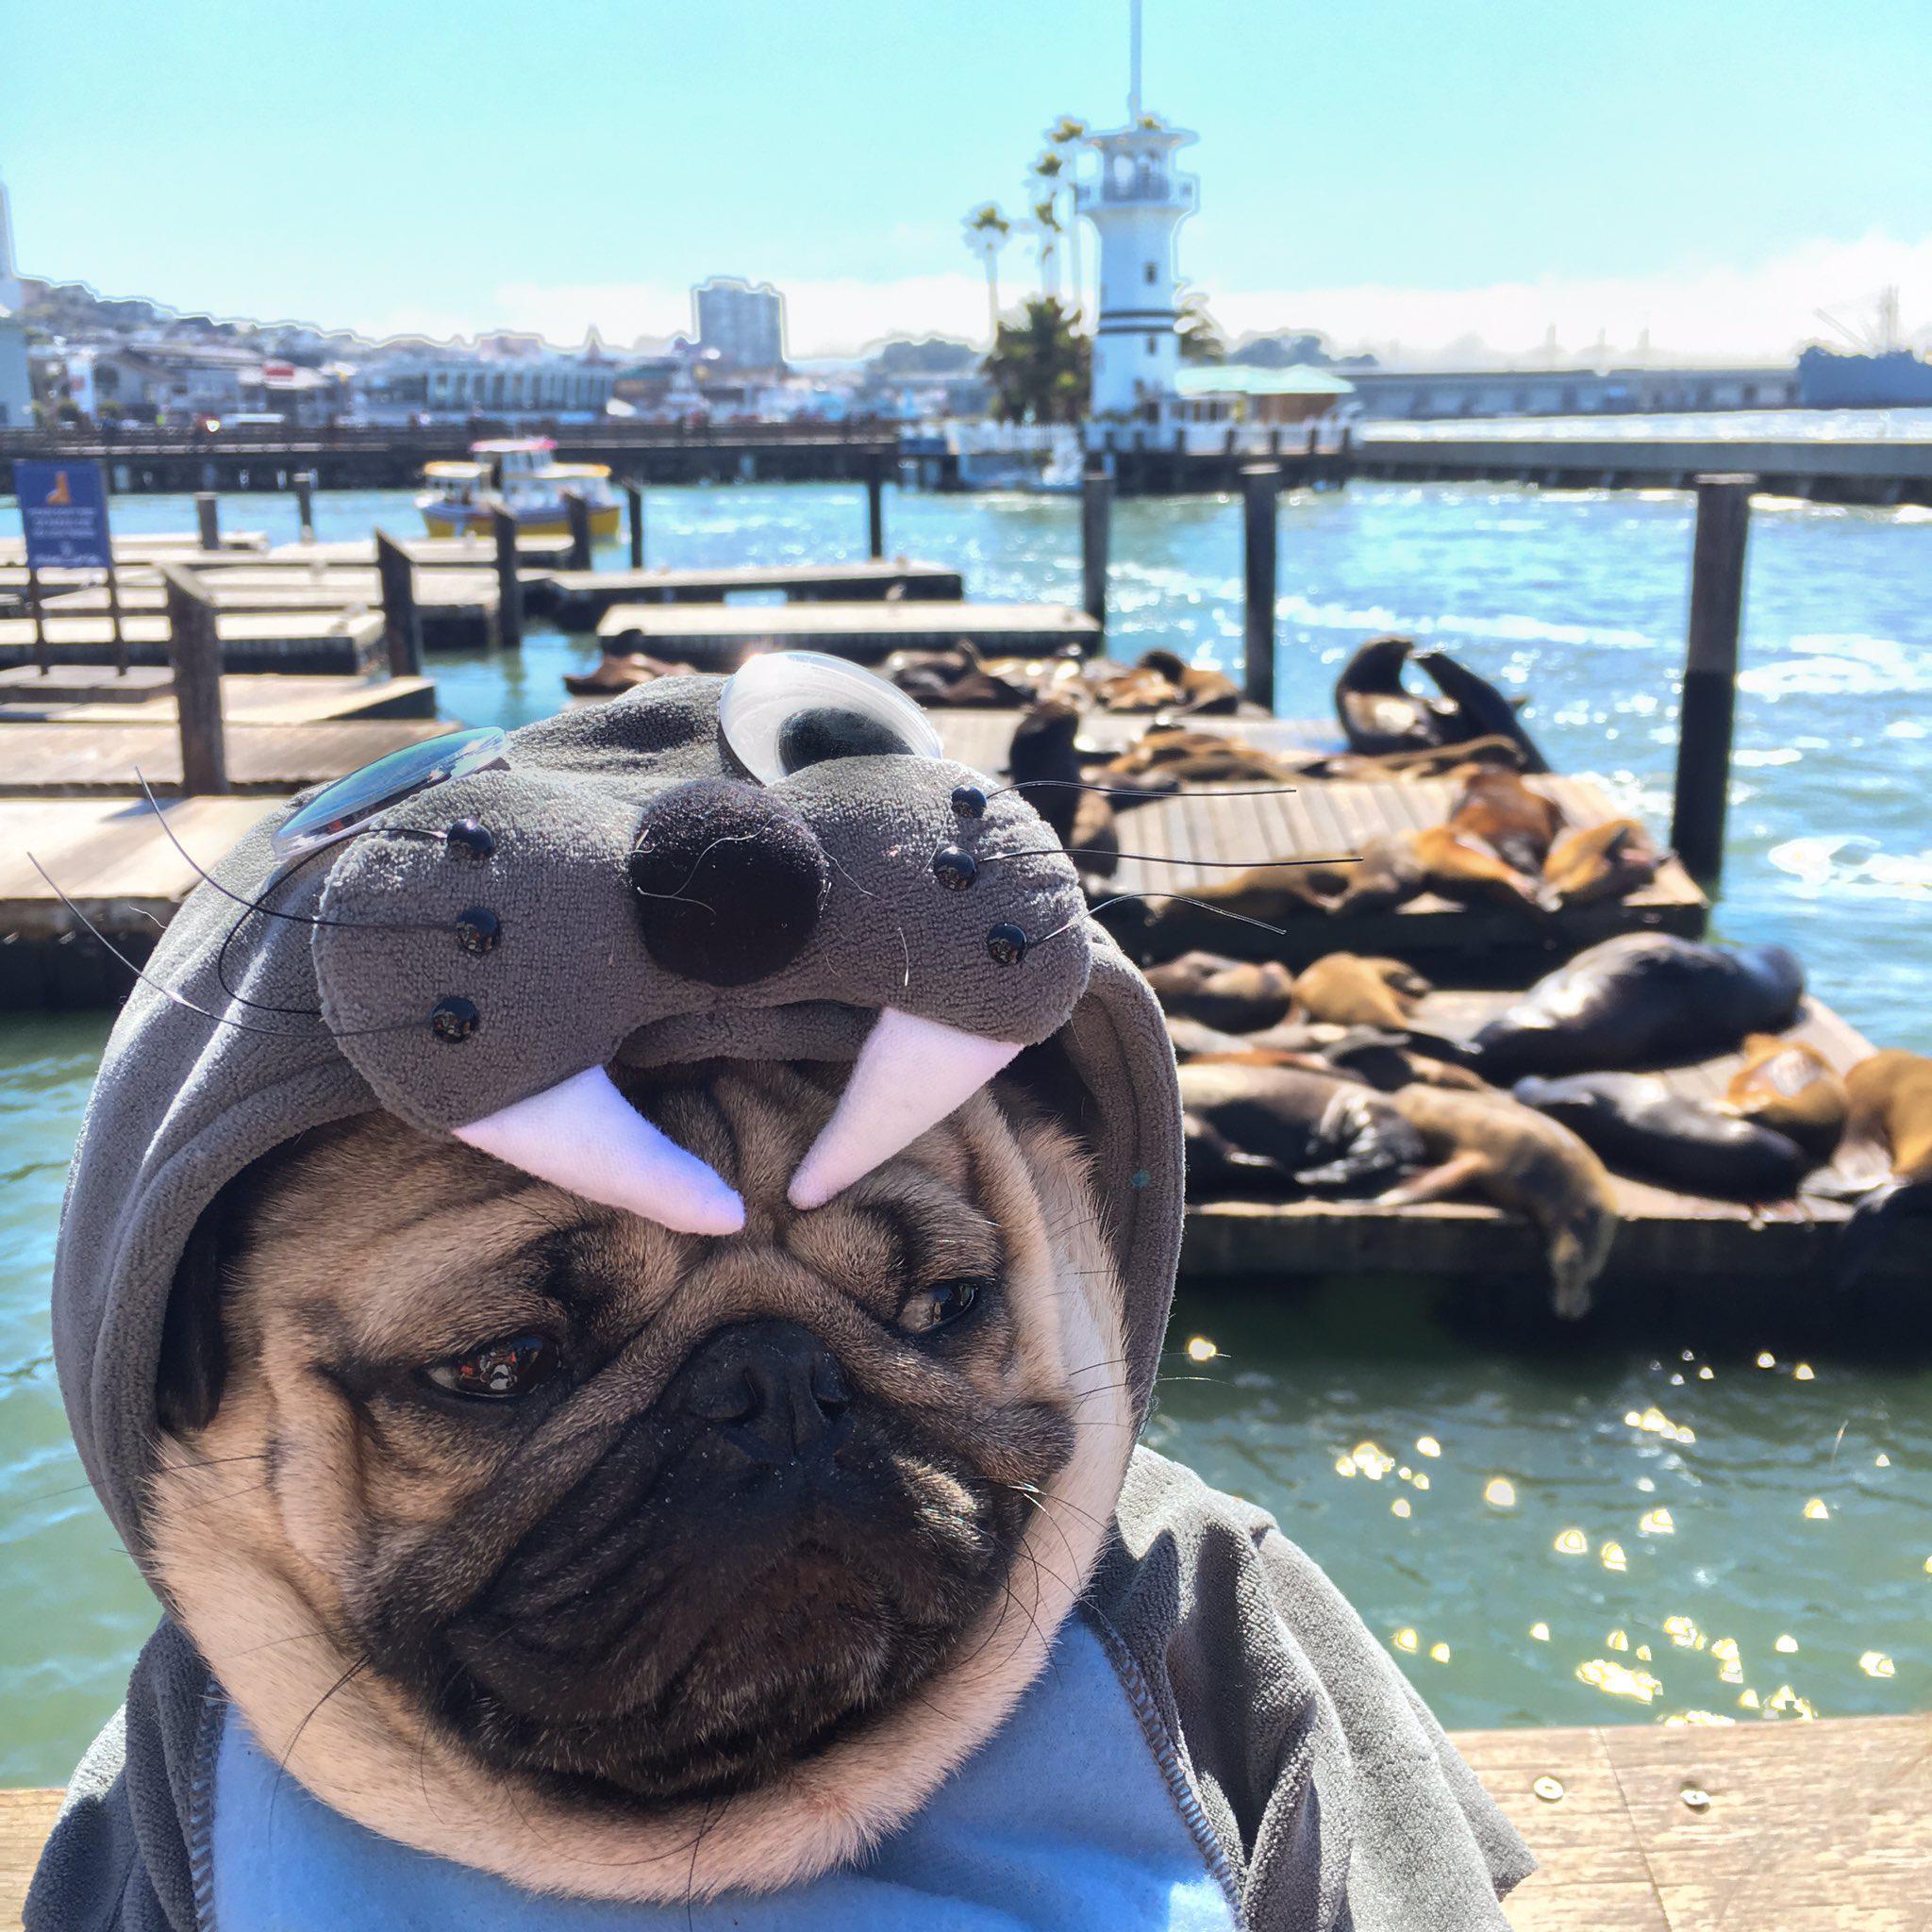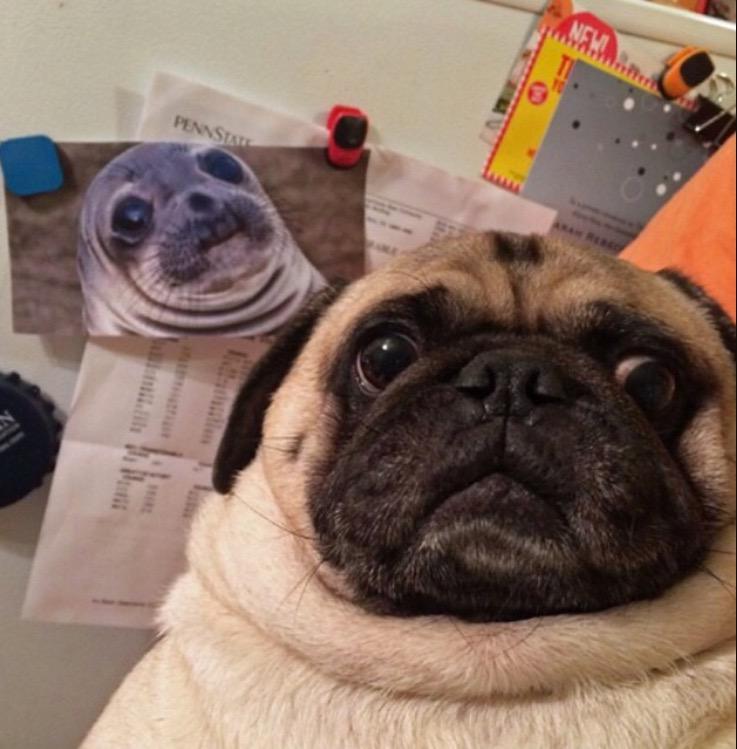The first image is the image on the left, the second image is the image on the right. Given the left and right images, does the statement "Exactly one pug dog is shown in a scene with water." hold true? Answer yes or no. Yes. The first image is the image on the left, the second image is the image on the right. Given the left and right images, does the statement "The dog on the left is near an area of water." hold true? Answer yes or no. Yes. 